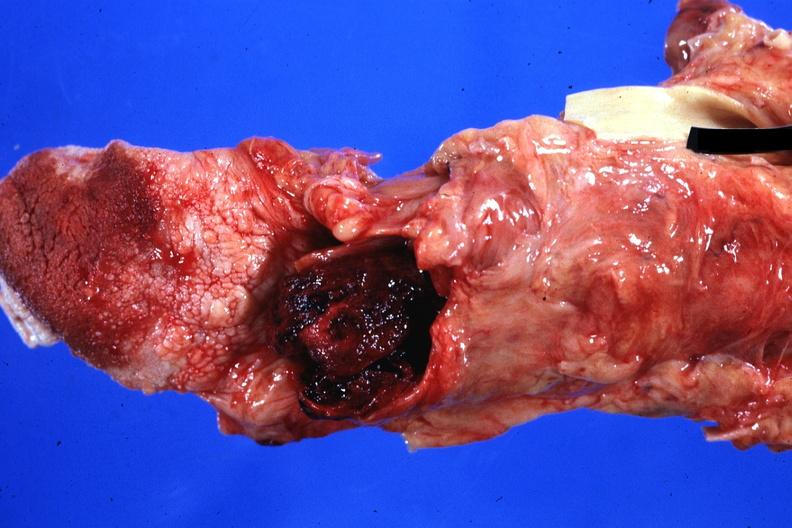how is blood clot standing case of myeloproliferative disorder?
Answer the question using a single word or phrase. Terminal acute transformation and bleeding 